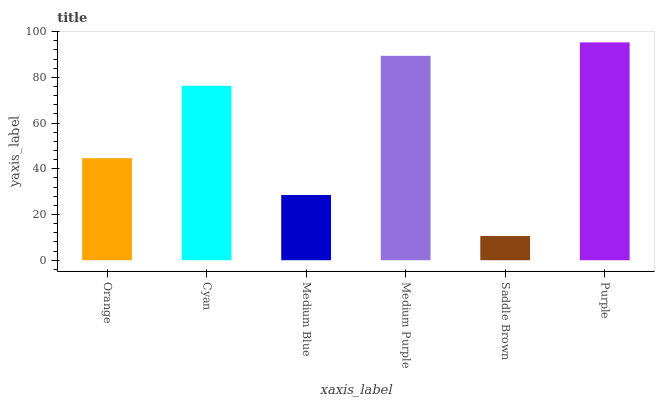Is Saddle Brown the minimum?
Answer yes or no. Yes. Is Purple the maximum?
Answer yes or no. Yes. Is Cyan the minimum?
Answer yes or no. No. Is Cyan the maximum?
Answer yes or no. No. Is Cyan greater than Orange?
Answer yes or no. Yes. Is Orange less than Cyan?
Answer yes or no. Yes. Is Orange greater than Cyan?
Answer yes or no. No. Is Cyan less than Orange?
Answer yes or no. No. Is Cyan the high median?
Answer yes or no. Yes. Is Orange the low median?
Answer yes or no. Yes. Is Saddle Brown the high median?
Answer yes or no. No. Is Saddle Brown the low median?
Answer yes or no. No. 